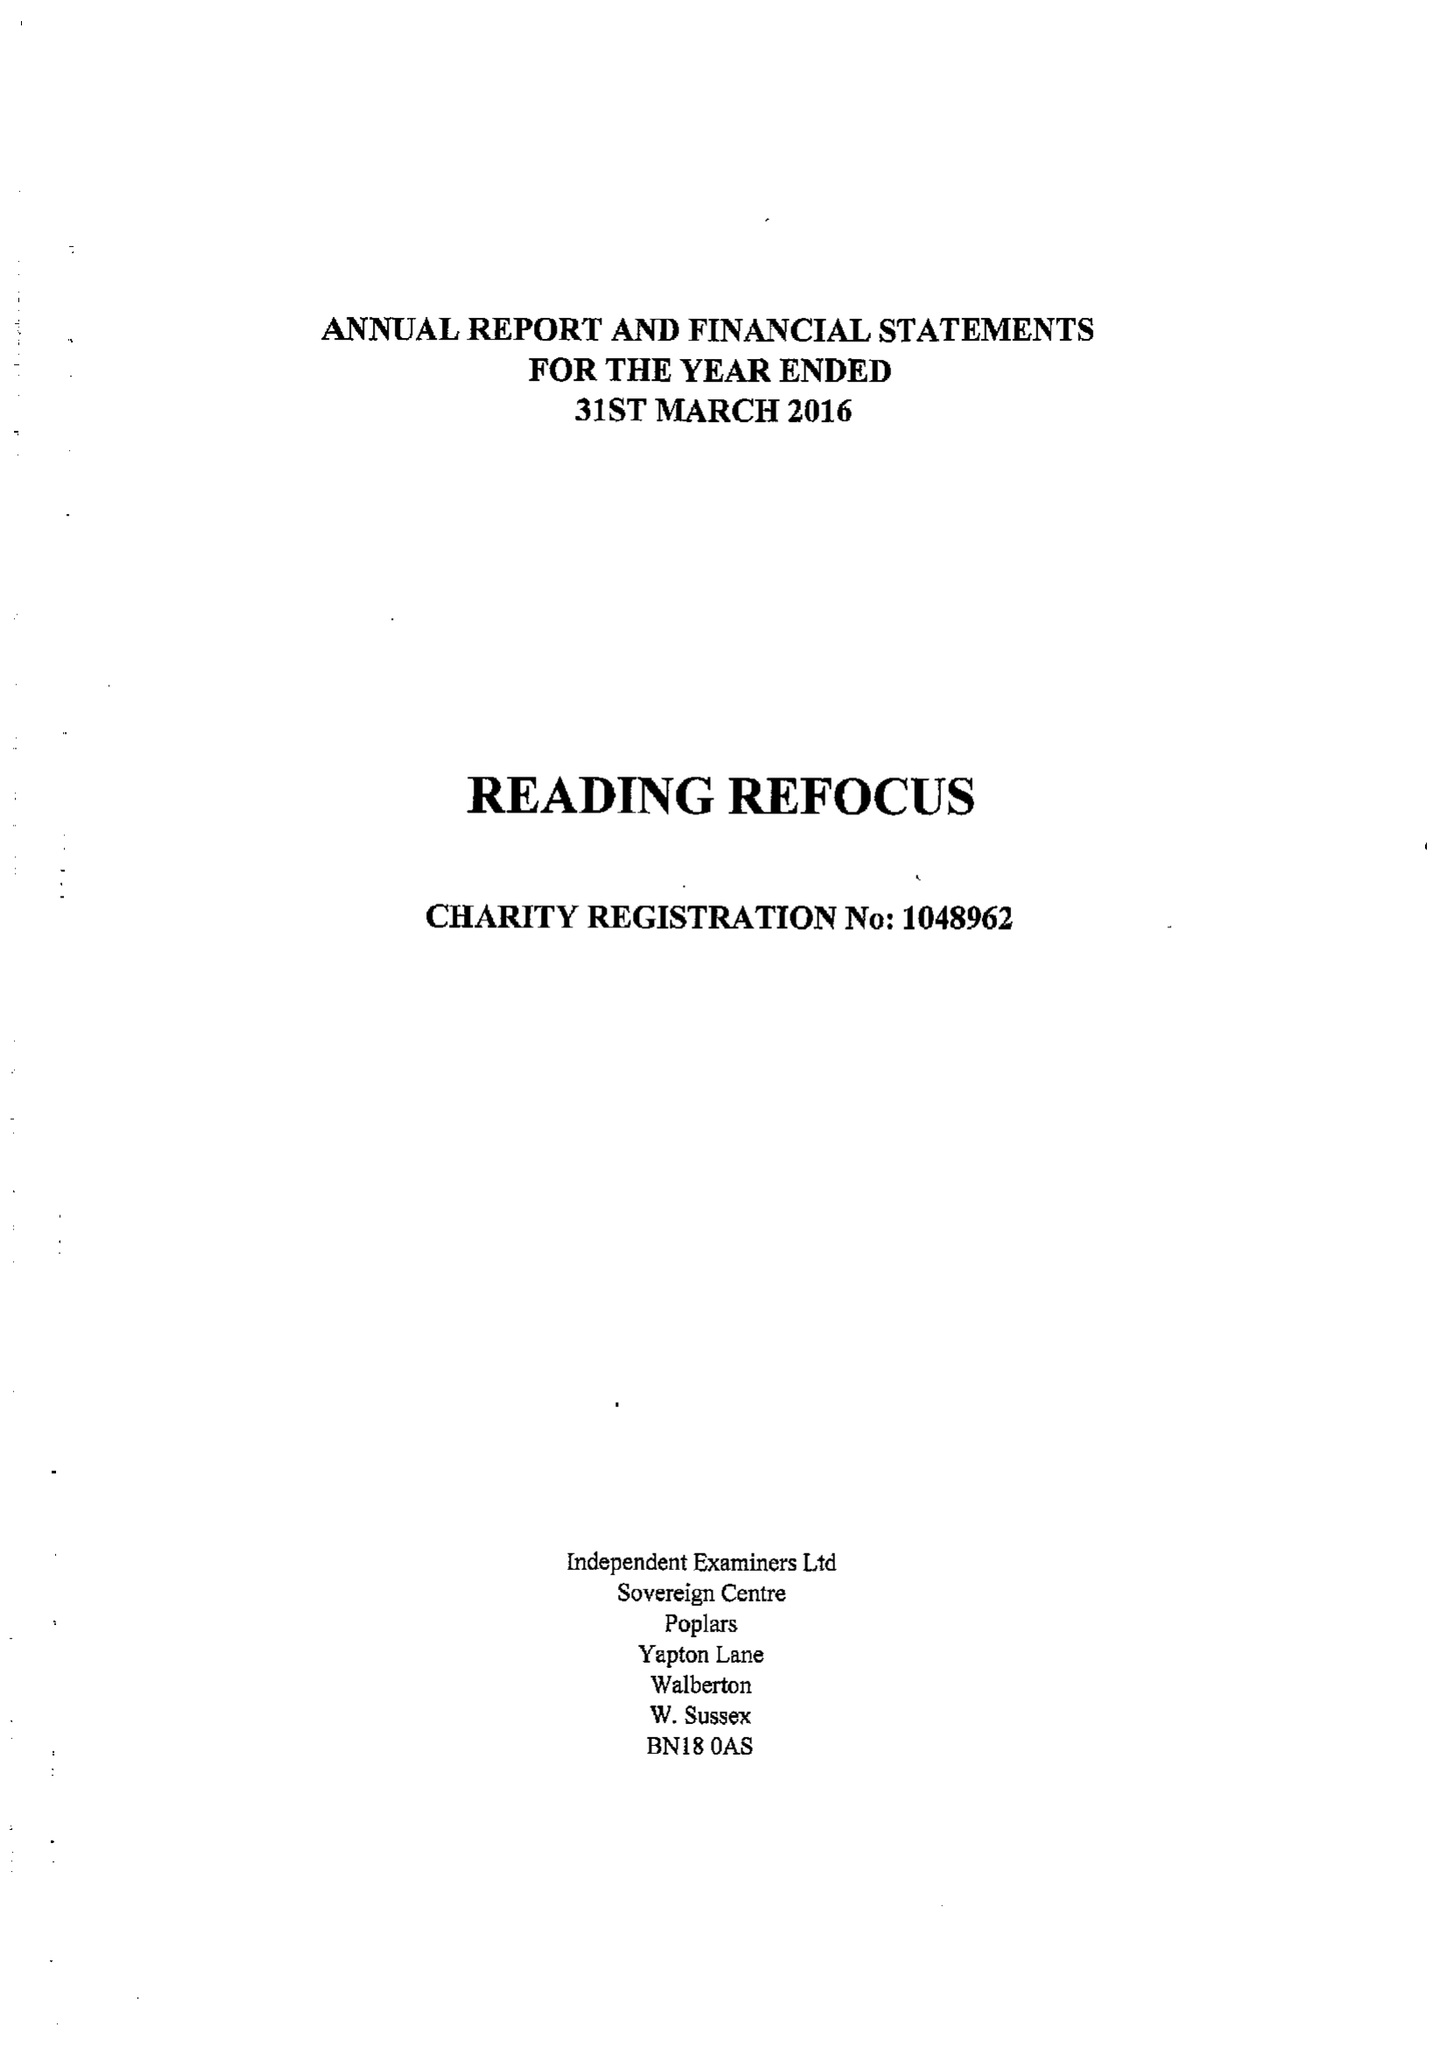What is the value for the income_annually_in_british_pounds?
Answer the question using a single word or phrase. 50617.00 